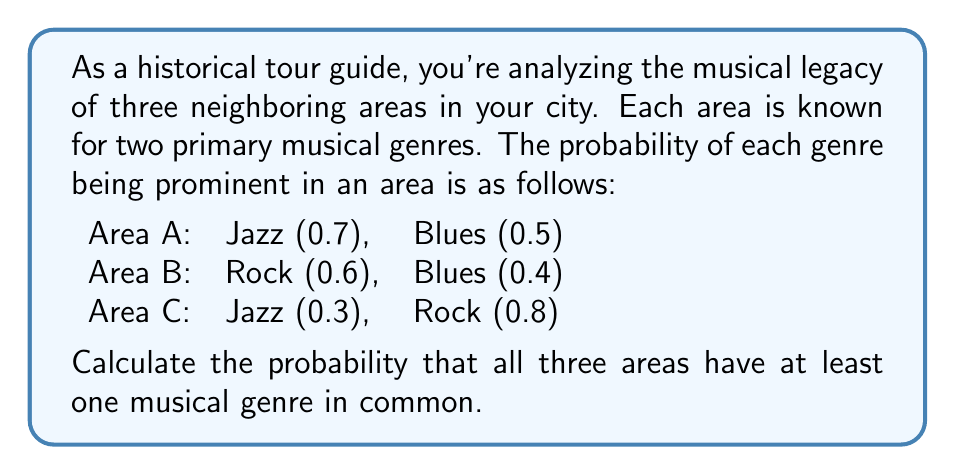Help me with this question. Let's approach this step-by-step:

1) First, we need to find the probability of each area not having a specific genre:

   Area A: P(No Jazz) = 0.3, P(No Blues) = 0.5
   Area B: P(No Rock) = 0.4, P(No Blues) = 0.6
   Area C: P(No Jazz) = 0.7, P(No Rock) = 0.2

2) Now, for all areas to have at least one genre in common, we need to calculate the probability that it's not the case that all genres are missing from at least one area. Let's call this event E.

3) P(E) = 1 - P(No common genre)

4) For no common genre:
   - Jazz must be missing from A or C
   - Rock must be missing from B or C
   - Blues must be missing from A or B

5) P(No common genre) = P((No Jazz in A or C) AND (No Rock in B or C) AND (No Blues in A or B))

6) Assuming independence:
   
   P(No common genre) = P(No Jazz in A or C) * P(No Rock in B or C) * P(No Blues in A or B)

7) Calculate each part:
   
   P(No Jazz in A or C) = 0.3 * 0.7 = 0.21
   P(No Rock in B or C) = 0.4 * 0.2 = 0.08
   P(No Blues in A or B) = 0.5 * 0.6 = 0.3

8) P(No common genre) = 0.21 * 0.08 * 0.3 = 0.00504

9) Therefore, P(E) = 1 - 0.00504 = 0.99496
Answer: The probability that all three areas have at least one musical genre in common is approximately 0.99496 or 99.496%. 